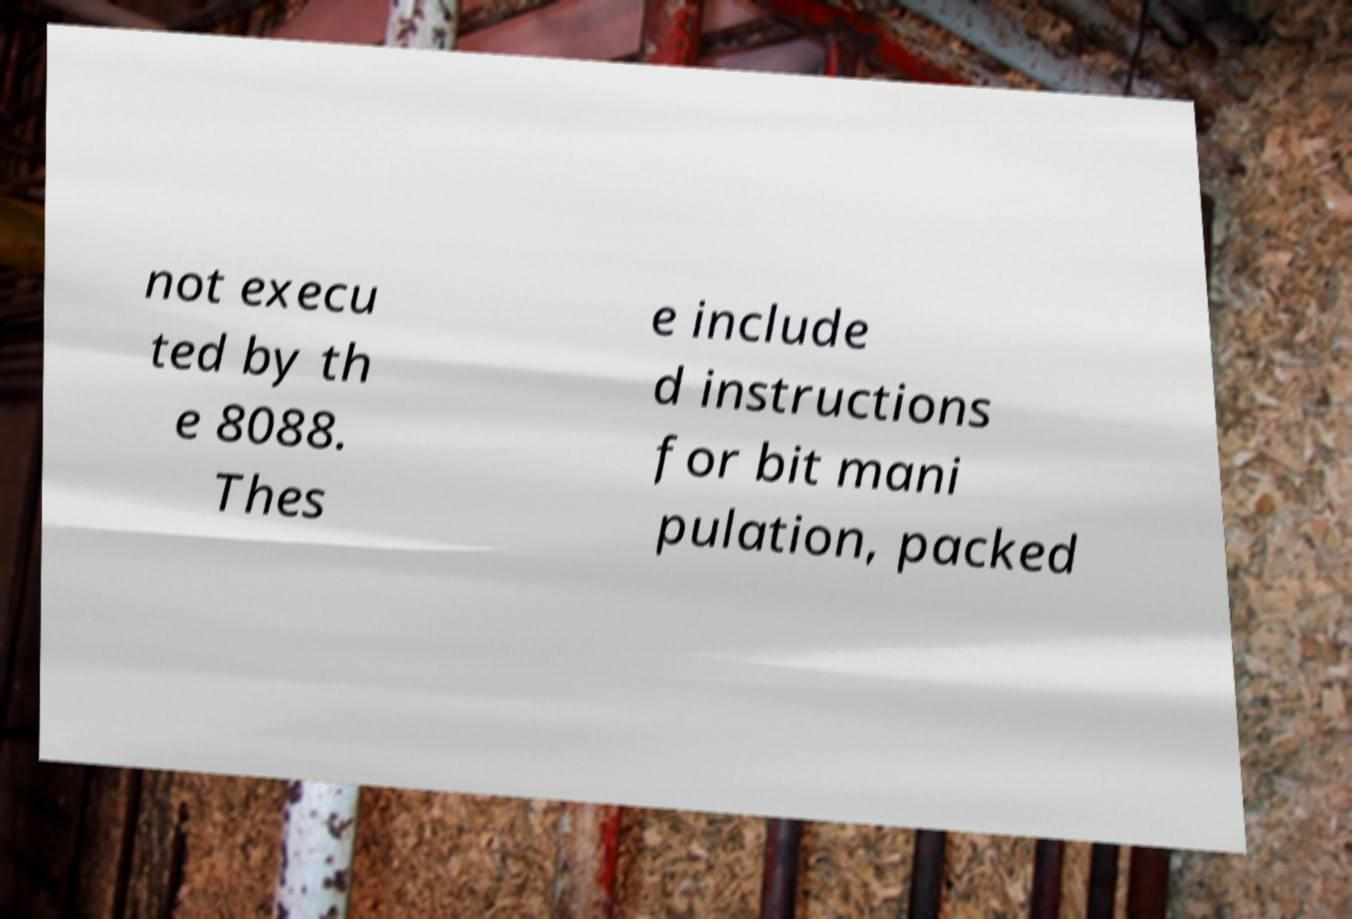There's text embedded in this image that I need extracted. Can you transcribe it verbatim? not execu ted by th e 8088. Thes e include d instructions for bit mani pulation, packed 